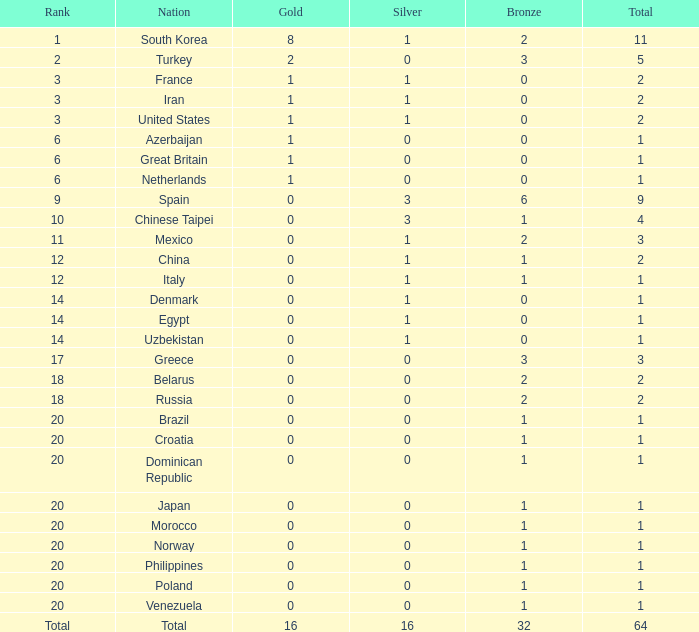What is the average number of bronze medals of the Philippines, which has more than 0 gold? None. 